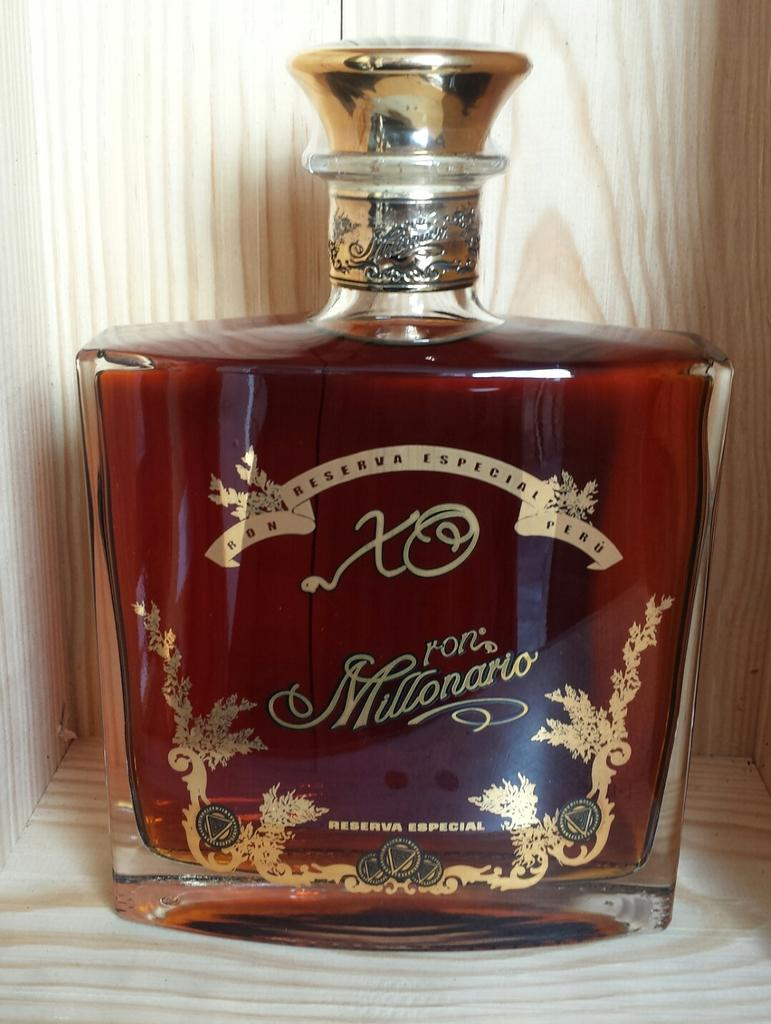Provide a one-sentence caption for the provided image. A bottle that has the letters XO and the name Ron Millonario on it. 